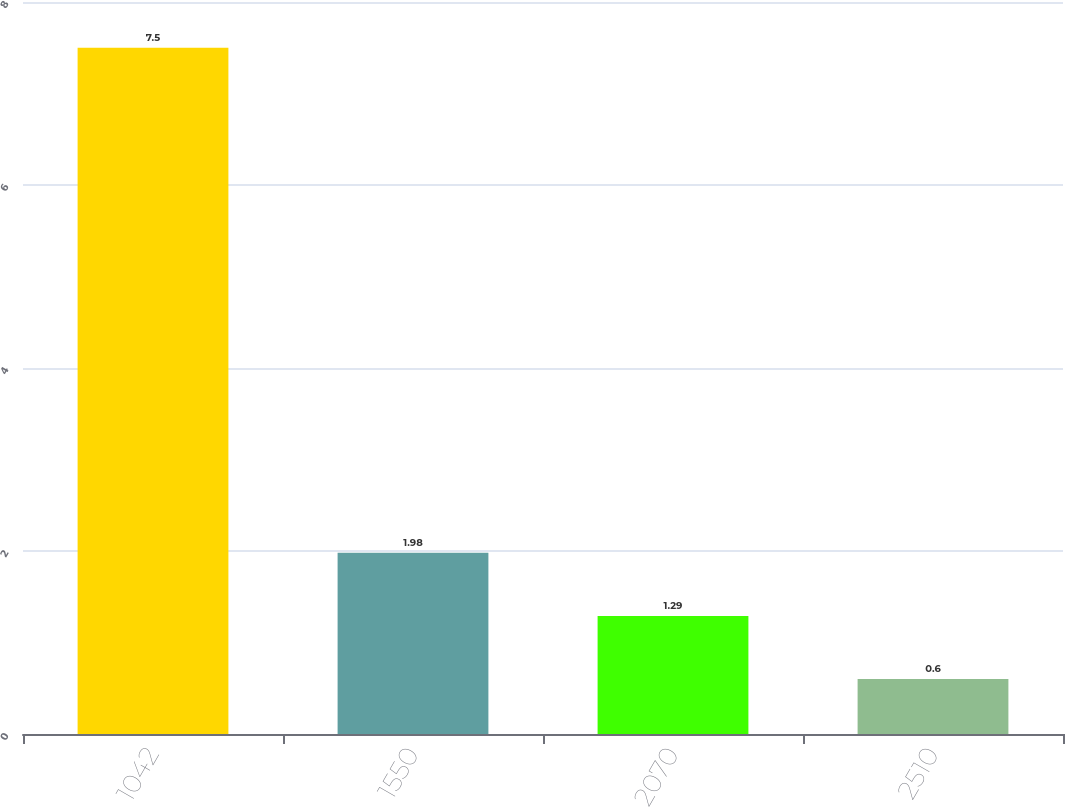<chart> <loc_0><loc_0><loc_500><loc_500><bar_chart><fcel>1042<fcel>1550<fcel>2070<fcel>2510<nl><fcel>7.5<fcel>1.98<fcel>1.29<fcel>0.6<nl></chart> 